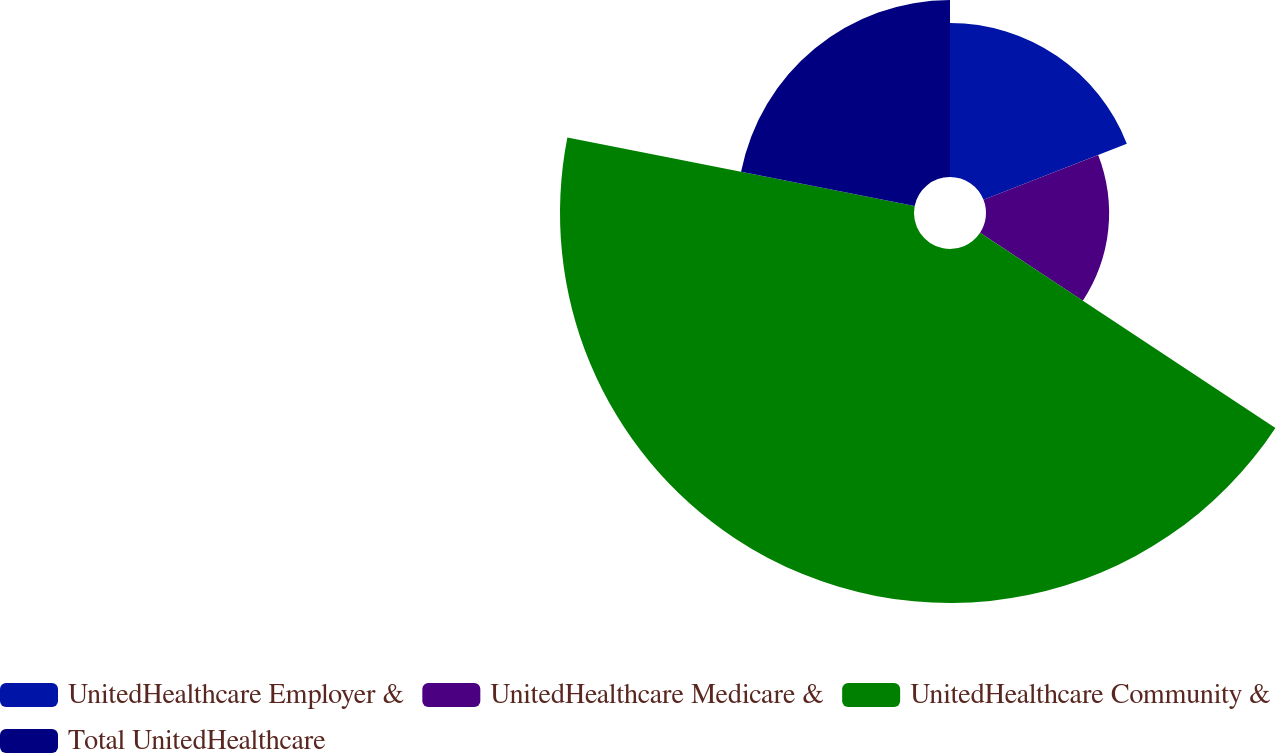Convert chart to OTSL. <chart><loc_0><loc_0><loc_500><loc_500><pie_chart><fcel>UnitedHealthcare Employer &<fcel>UnitedHealthcare Medicare &<fcel>UnitedHealthcare Community &<fcel>Total UnitedHealthcare<nl><fcel>19.05%<fcel>15.24%<fcel>43.81%<fcel>21.9%<nl></chart> 